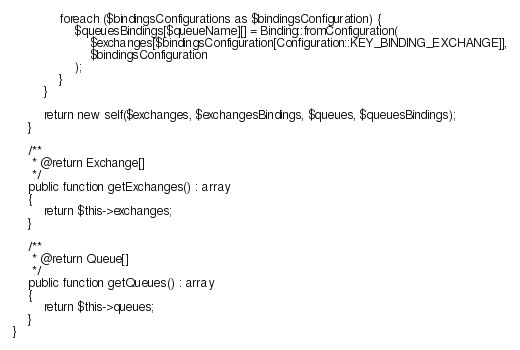<code> <loc_0><loc_0><loc_500><loc_500><_PHP_>            foreach ($bindingsConfigurations as $bindingsConfiguration) {
                $queuesBindings[$queueName][] = Binding::fromConfiguration(
                    $exchanges[$bindingsConfiguration[Configuration::KEY_BINDING_EXCHANGE]],
                    $bindingsConfiguration
                );
            }
        }

        return new self($exchanges, $exchangesBindings, $queues, $queuesBindings);
    }

    /**
     * @return Exchange[]
     */
    public function getExchanges() : array
    {
        return $this->exchanges;
    }

    /**
     * @return Queue[]
     */
    public function getQueues() : array
    {
        return $this->queues;
    }
}
</code> 